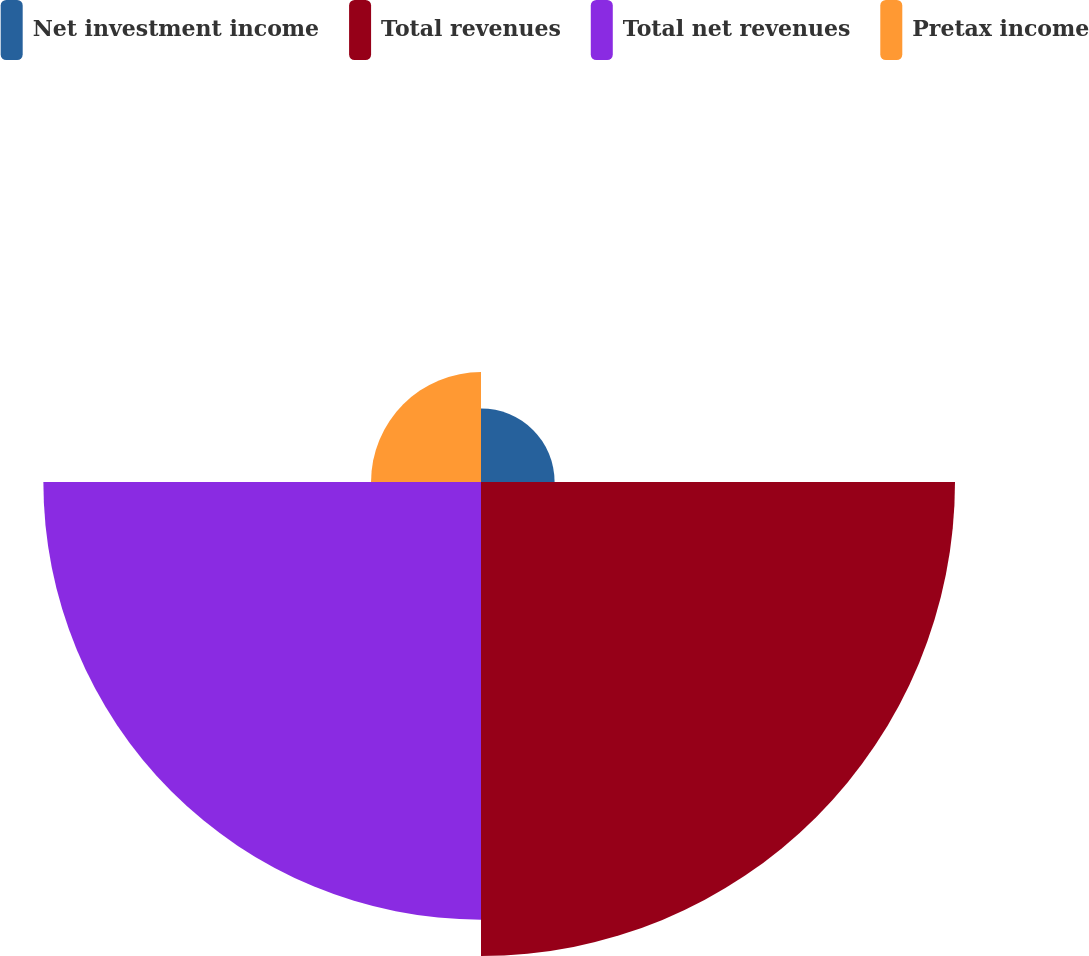Convert chart to OTSL. <chart><loc_0><loc_0><loc_500><loc_500><pie_chart><fcel>Net investment income<fcel>Total revenues<fcel>Total net revenues<fcel>Pretax income<nl><fcel>6.72%<fcel>43.28%<fcel>39.96%<fcel>10.04%<nl></chart> 